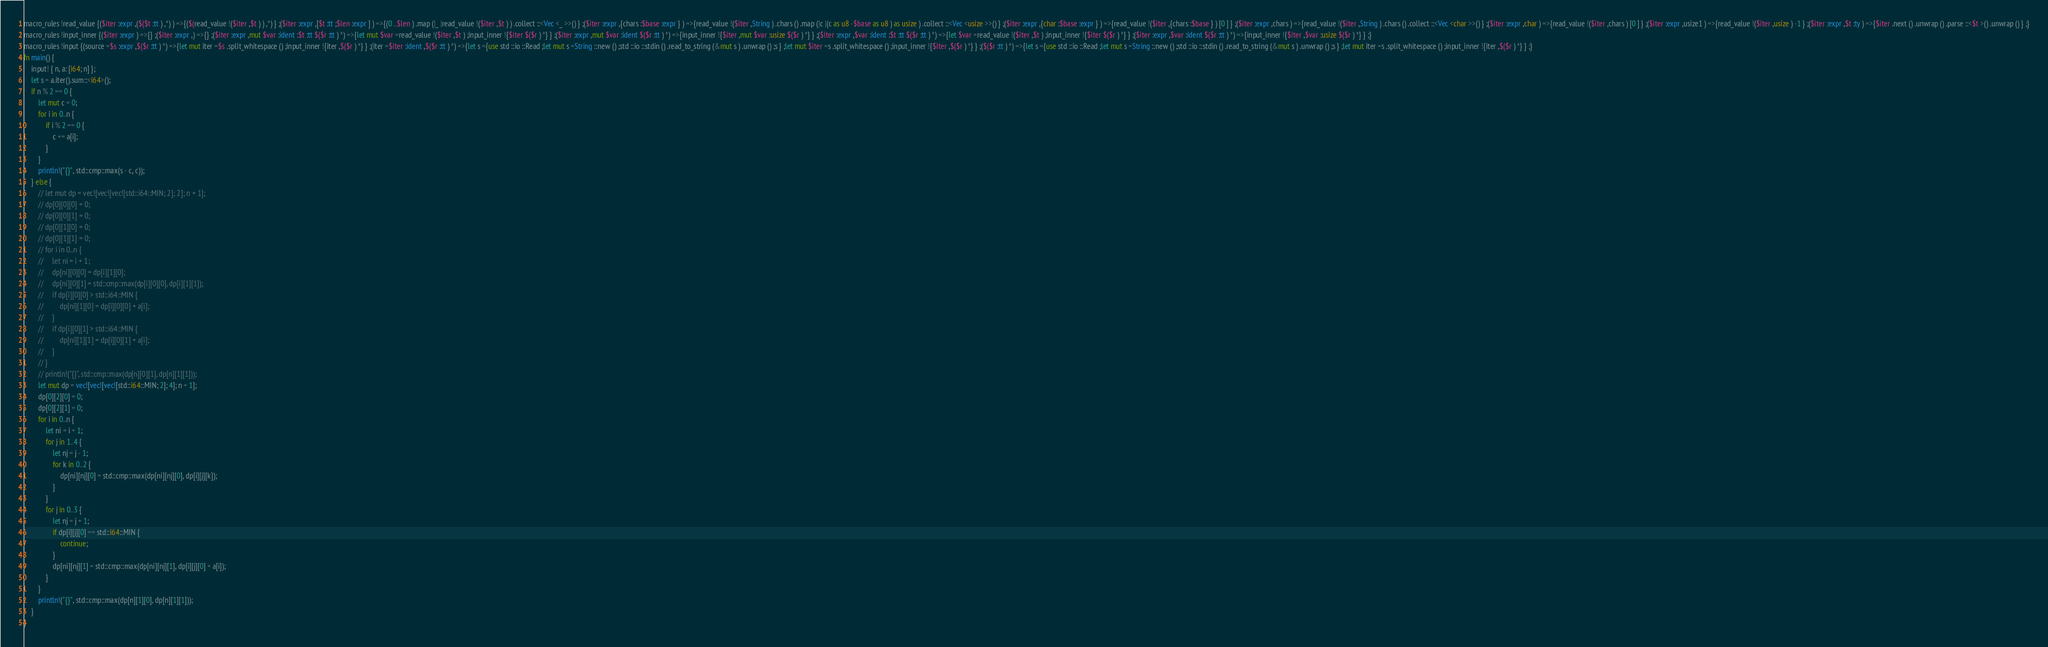Convert code to text. <code><loc_0><loc_0><loc_500><loc_500><_Rust_>macro_rules !read_value {($iter :expr ,($($t :tt ) ,*) ) =>{($(read_value !($iter ,$t ) ) ,*) } ;($iter :expr ,[$t :tt ;$len :expr ] ) =>{(0 ..$len ) .map (|_ |read_value !($iter ,$t ) ) .collect ::<Vec <_ >>() } ;($iter :expr ,{chars :$base :expr } ) =>{read_value !($iter ,String ) .chars () .map (|c |(c as u8 -$base as u8 ) as usize ) .collect ::<Vec <usize >>() } ;($iter :expr ,{char :$base :expr } ) =>{read_value !($iter ,{chars :$base } ) [0 ] } ;($iter :expr ,chars ) =>{read_value !($iter ,String ) .chars () .collect ::<Vec <char >>() } ;($iter :expr ,char ) =>{read_value !($iter ,chars ) [0 ] } ;($iter :expr ,usize1 ) =>{read_value !($iter ,usize ) -1 } ;($iter :expr ,$t :ty ) =>{$iter .next () .unwrap () .parse ::<$t >() .unwrap () } ;}
macro_rules !input_inner {($iter :expr ) =>{} ;($iter :expr ,) =>{} ;($iter :expr ,mut $var :ident :$t :tt $($r :tt ) *) =>{let mut $var =read_value !($iter ,$t ) ;input_inner !{$iter $($r ) *} } ;($iter :expr ,mut $var :ident $($r :tt ) *) =>{input_inner !{$iter ,mut $var :usize $($r ) *} } ;($iter :expr ,$var :ident :$t :tt $($r :tt ) *) =>{let $var =read_value !($iter ,$t ) ;input_inner !{$iter $($r ) *} } ;($iter :expr ,$var :ident $($r :tt ) *) =>{input_inner !{$iter ,$var :usize $($r ) *} } ;}
macro_rules !input {(source =$s :expr ,$($r :tt ) *) =>{let mut iter =$s .split_whitespace () ;input_inner !{iter ,$($r ) *} } ;(iter =$iter :ident ,$($r :tt ) *) =>{let s ={use std ::io ::Read ;let mut s =String ::new () ;std ::io ::stdin () .read_to_string (&mut s ) .unwrap () ;s } ;let mut $iter =s .split_whitespace () ;input_inner !{$iter ,$($r ) *} } ;($($r :tt ) *) =>{let s ={use std ::io ::Read ;let mut s =String ::new () ;std ::io ::stdin () .read_to_string (&mut s ) .unwrap () ;s } ;let mut iter =s .split_whitespace () ;input_inner !{iter ,$($r ) *} } ;}
fn main() {
    input! { n, a: [i64; n] };
    let s = a.iter().sum::<i64>();
    if n % 2 == 0 {
        let mut c = 0;
        for i in 0..n {
            if i % 2 == 0 {
                c += a[i];
            }
        }
        println!("{}", std::cmp::max(s - c, c));
    } else {
        // let mut dp = vec![vec![vec![std::i64::MIN; 2]; 2]; n + 1];
        // dp[0][0][0] = 0;
        // dp[0][0][1] = 0;
        // dp[0][1][0] = 0;
        // dp[0][1][1] = 0;
        // for i in 0..n {
        //     let ni = i + 1;
        //     dp[ni][0][0] = dp[i][1][0];
        //     dp[ni][0][1] = std::cmp::max(dp[i][0][0], dp[i][1][1]);
        //     if dp[i][0][0] > std::i64::MIN {
        //         dp[ni][1][0] = dp[i][0][0] + a[i];
        //     }
        //     if dp[i][0][1] > std::i64::MIN {
        //         dp[ni][1][1] = dp[i][0][1] + a[i];
        //     }
        // }
        // println!("{}", std::cmp::max(dp[n][0][1], dp[n][1][1]));
        let mut dp = vec![vec![vec![std::i64::MIN; 2]; 4]; n + 1];
        dp[0][2][0] = 0;
        dp[0][2][1] = 0;
        for i in 0..n {
            let ni = i + 1;
            for j in 1..4 {
                let nj = j - 1;
                for k in 0..2 {
                    dp[ni][nj][0] = std::cmp::max(dp[ni][nj][0], dp[i][j][k]);
                }
            }
            for j in 0..3 {
                let nj = j + 1;
                if dp[i][j][0] == std::i64::MIN {
                    continue;
                }
                dp[ni][nj][1] = std::cmp::max(dp[ni][nj][1], dp[i][j][0] + a[i]);
            }
        }
        println!("{}", std::cmp::max(dp[n][1][0], dp[n][1][1]));
    }
}
</code> 